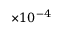<formula> <loc_0><loc_0><loc_500><loc_500>\times 1 0 ^ { - 4 }</formula> 